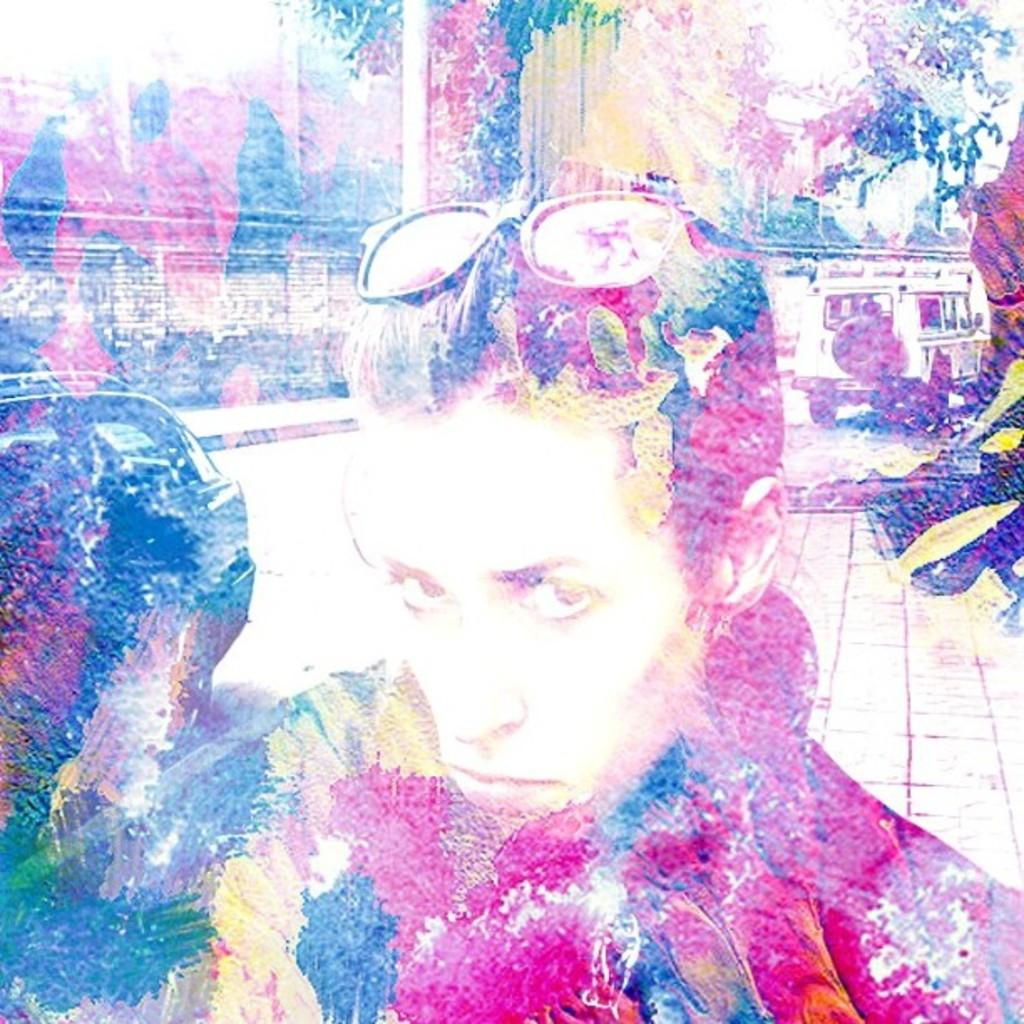What is the main subject in the foreground of the image? There is a man in the foreground of the image. What is the man wearing in the image? The man is wearing glasses in the image. What can be seen in the background of the image? There are vehicles, a wall, trees, and poles in the background of the image. What type of grain is being harvested in the image? There is no grain or harvesting activity present in the image. What angle is the man standing at in the image? The angle at which the man is standing cannot be determined from the image alone. 